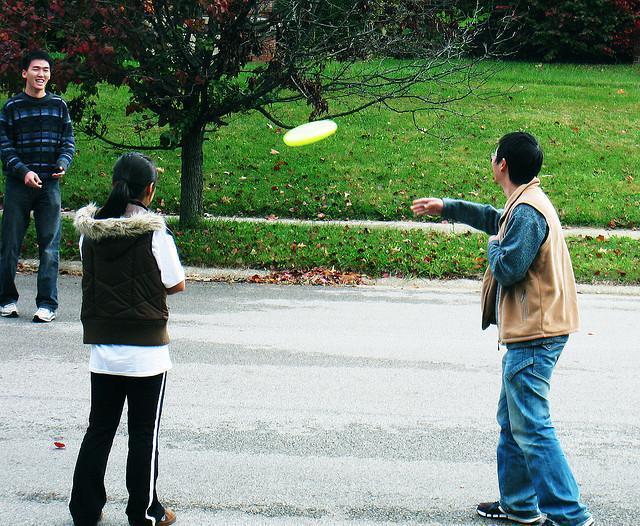How many people are there?
Give a very brief answer. 3. 